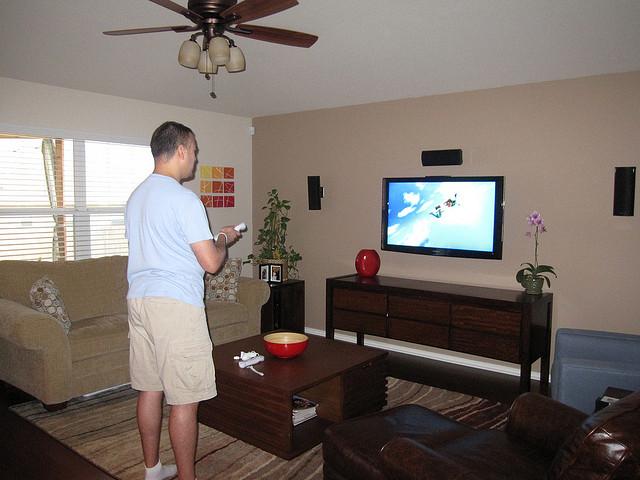What is growing next to the television?
Write a very short answer. Flower. What color vase is in front of the TV?
Write a very short answer. Red. Is this man wearing shoes?
Be succinct. No. 